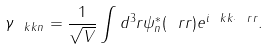<formula> <loc_0><loc_0><loc_500><loc_500>\gamma _ { \ k k n } = \frac { 1 } { \sqrt { V } } \int d ^ { 3 } r \psi _ { n } ^ { * } ( \ r r ) e ^ { i \ k k \cdot \ r r } .</formula> 